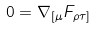<formula> <loc_0><loc_0><loc_500><loc_500>0 = \nabla _ { [ \mu } F _ { \rho \tau ] }</formula> 